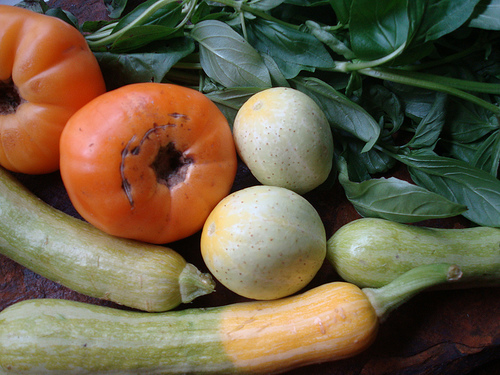<image>
Is the tomato to the left of the cucumber? No. The tomato is not to the left of the cucumber. From this viewpoint, they have a different horizontal relationship. 